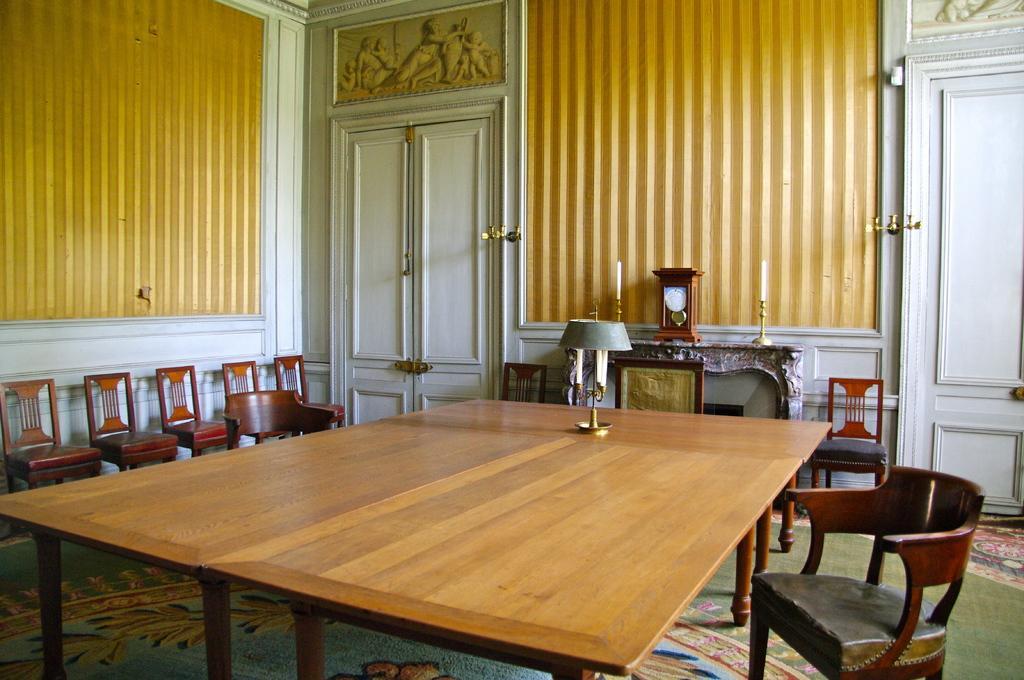Could you give a brief overview of what you see in this image? This picture describes about inside view of a room, in this we can find few chairs, table, lights and doors. 